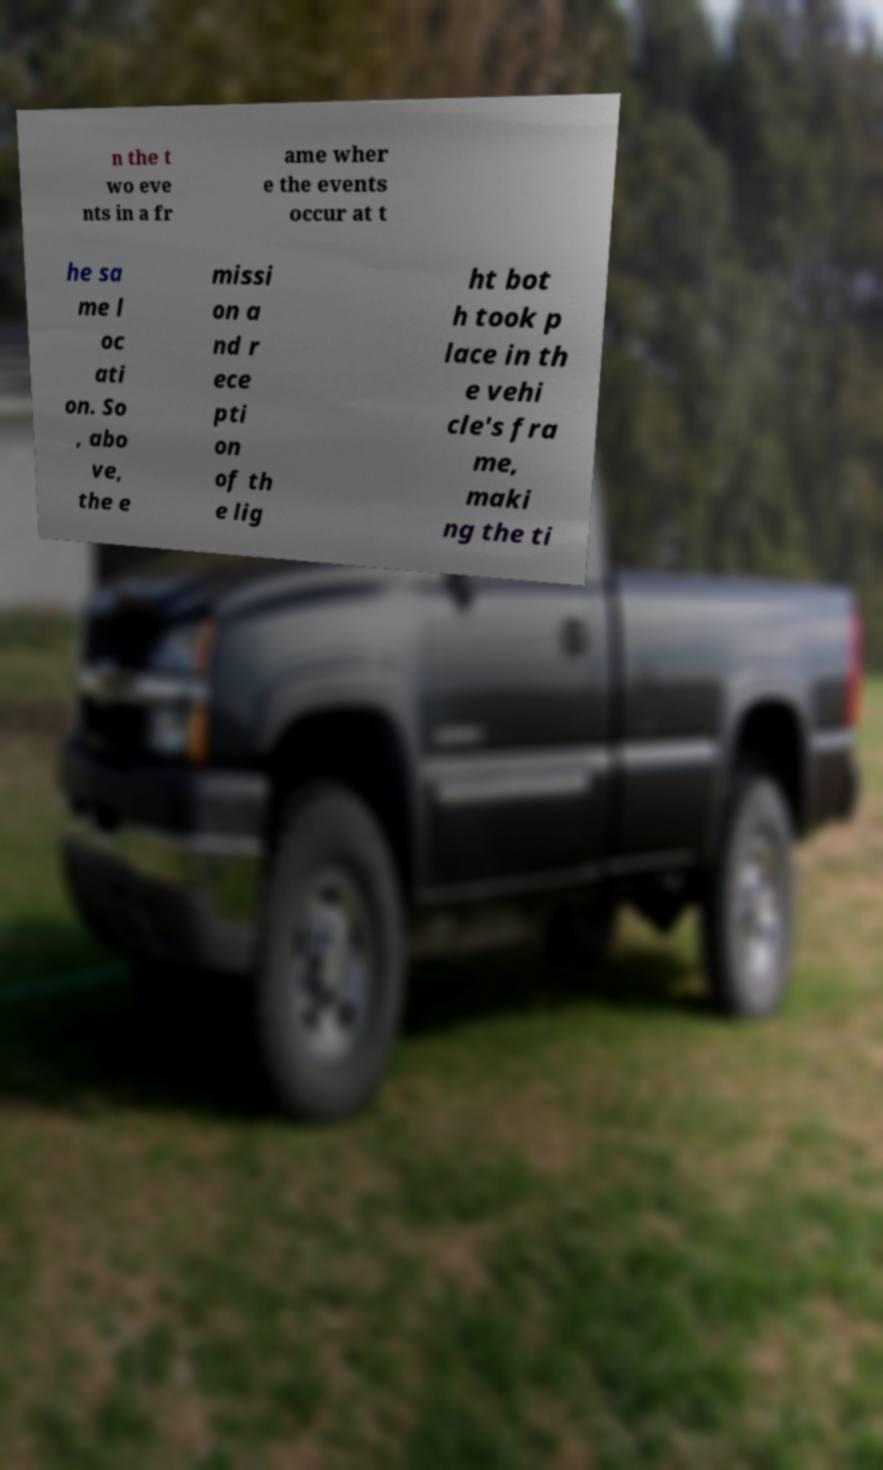What messages or text are displayed in this image? I need them in a readable, typed format. n the t wo eve nts in a fr ame wher e the events occur at t he sa me l oc ati on. So , abo ve, the e missi on a nd r ece pti on of th e lig ht bot h took p lace in th e vehi cle's fra me, maki ng the ti 